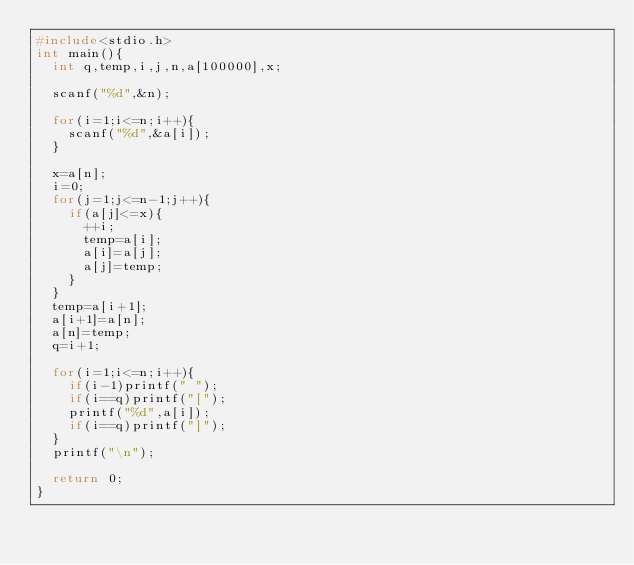Convert code to text. <code><loc_0><loc_0><loc_500><loc_500><_C_>#include<stdio.h>
int main(){
  int q,temp,i,j,n,a[100000],x;

  scanf("%d",&n);

  for(i=1;i<=n;i++){
    scanf("%d",&a[i]);
  }

  x=a[n];
  i=0;
  for(j=1;j<=n-1;j++){
    if(a[j]<=x){
      ++i;
      temp=a[i];
      a[i]=a[j];
      a[j]=temp;
    }
  }
  temp=a[i+1];
  a[i+1]=a[n];
  a[n]=temp;
  q=i+1;

  for(i=1;i<=n;i++){
    if(i-1)printf(" ");
    if(i==q)printf("[");
    printf("%d",a[i]);
    if(i==q)printf("]");
  }
  printf("\n");

  return 0;
}
  

</code> 